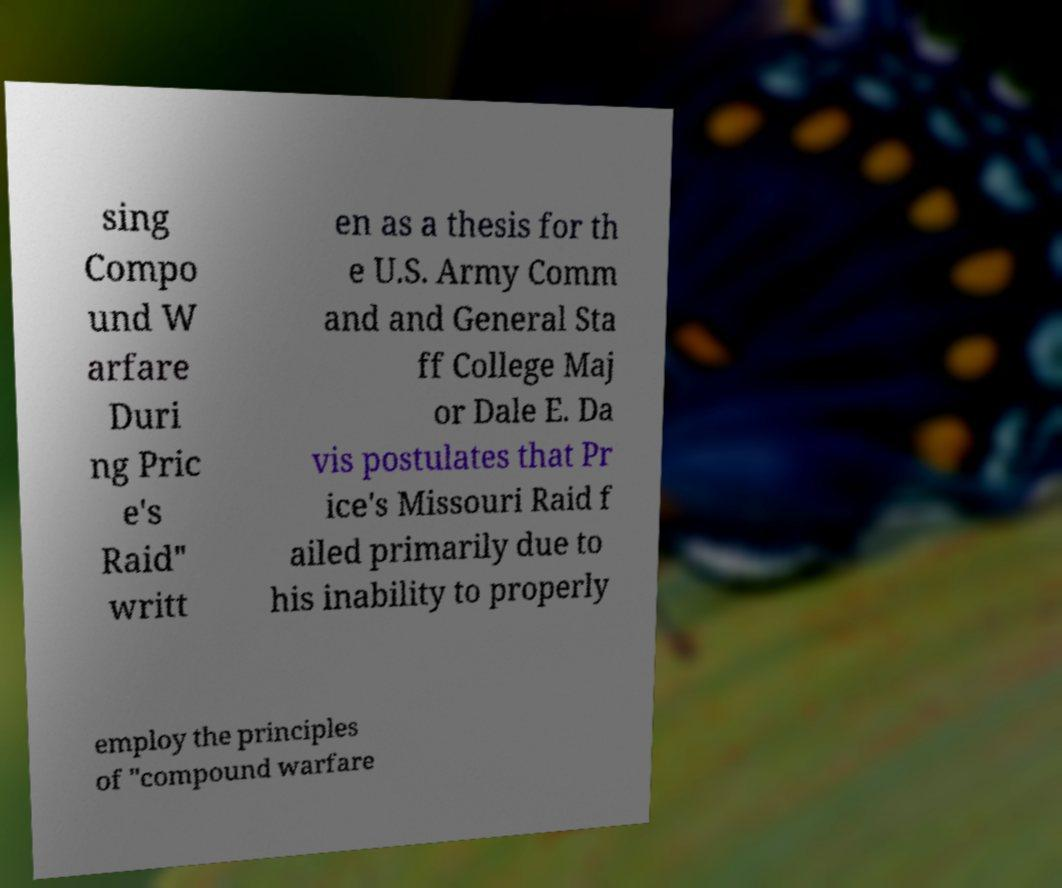Could you extract and type out the text from this image? sing Compo und W arfare Duri ng Pric e's Raid" writt en as a thesis for th e U.S. Army Comm and and General Sta ff College Maj or Dale E. Da vis postulates that Pr ice's Missouri Raid f ailed primarily due to his inability to properly employ the principles of "compound warfare 